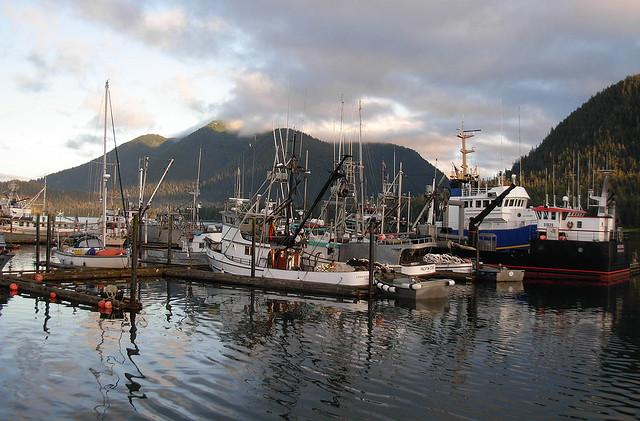What color are the lateral stripes wrapped around the black bodied boat? Please explain your reasoning. red. The black boat is clearly visible and the trim colors can been seen and identified. 